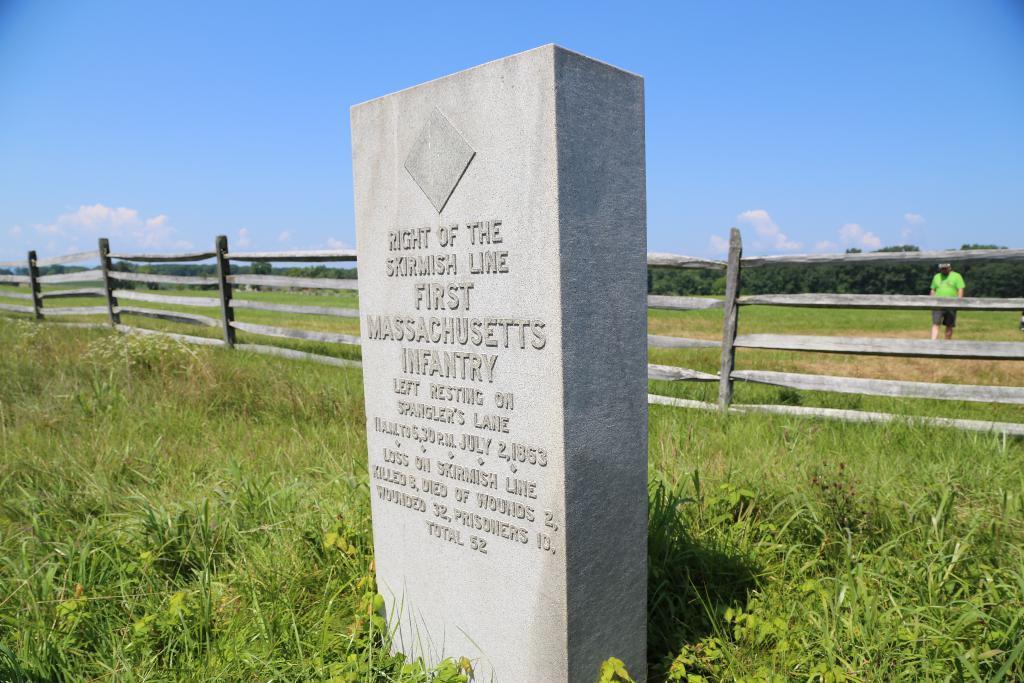Can you describe this image briefly? In this image we can see a stone and there is some text written on it, there is grass around it and behind it there is a fence, on the other side of the fence there is a person walking, in the background there are trees and there are clouds in the sky. 